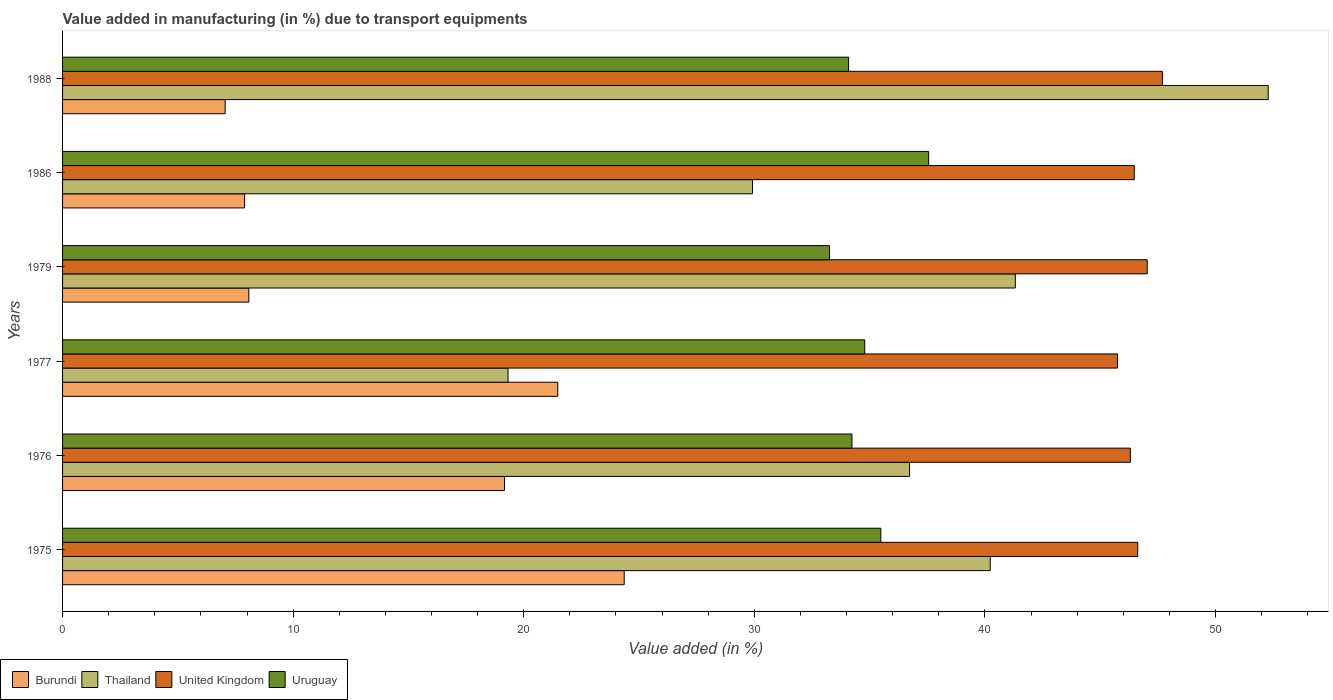Are the number of bars on each tick of the Y-axis equal?
Offer a very short reply. Yes. What is the label of the 5th group of bars from the top?
Your response must be concise. 1976. In how many cases, is the number of bars for a given year not equal to the number of legend labels?
Ensure brevity in your answer.  0. What is the percentage of value added in manufacturing due to transport equipments in Uruguay in 1988?
Keep it short and to the point. 34.09. Across all years, what is the maximum percentage of value added in manufacturing due to transport equipments in Thailand?
Offer a very short reply. 52.29. Across all years, what is the minimum percentage of value added in manufacturing due to transport equipments in Burundi?
Offer a terse response. 7.05. In which year was the percentage of value added in manufacturing due to transport equipments in United Kingdom maximum?
Provide a succinct answer. 1988. In which year was the percentage of value added in manufacturing due to transport equipments in Thailand minimum?
Your response must be concise. 1977. What is the total percentage of value added in manufacturing due to transport equipments in Uruguay in the graph?
Offer a very short reply. 209.43. What is the difference between the percentage of value added in manufacturing due to transport equipments in Burundi in 1977 and that in 1979?
Your answer should be compact. 13.4. What is the difference between the percentage of value added in manufacturing due to transport equipments in Thailand in 1977 and the percentage of value added in manufacturing due to transport equipments in Uruguay in 1976?
Provide a short and direct response. -14.92. What is the average percentage of value added in manufacturing due to transport equipments in Burundi per year?
Offer a terse response. 14.67. In the year 1977, what is the difference between the percentage of value added in manufacturing due to transport equipments in Burundi and percentage of value added in manufacturing due to transport equipments in United Kingdom?
Provide a short and direct response. -24.28. In how many years, is the percentage of value added in manufacturing due to transport equipments in Burundi greater than 12 %?
Your response must be concise. 3. What is the ratio of the percentage of value added in manufacturing due to transport equipments in United Kingdom in 1976 to that in 1986?
Ensure brevity in your answer.  1. Is the difference between the percentage of value added in manufacturing due to transport equipments in Burundi in 1975 and 1977 greater than the difference between the percentage of value added in manufacturing due to transport equipments in United Kingdom in 1975 and 1977?
Your answer should be compact. Yes. What is the difference between the highest and the second highest percentage of value added in manufacturing due to transport equipments in United Kingdom?
Make the answer very short. 0.66. What is the difference between the highest and the lowest percentage of value added in manufacturing due to transport equipments in Burundi?
Your response must be concise. 17.31. Is it the case that in every year, the sum of the percentage of value added in manufacturing due to transport equipments in Burundi and percentage of value added in manufacturing due to transport equipments in Thailand is greater than the sum of percentage of value added in manufacturing due to transport equipments in United Kingdom and percentage of value added in manufacturing due to transport equipments in Uruguay?
Give a very brief answer. No. What does the 4th bar from the bottom in 1988 represents?
Keep it short and to the point. Uruguay. How many years are there in the graph?
Make the answer very short. 6. What is the difference between two consecutive major ticks on the X-axis?
Provide a short and direct response. 10. Are the values on the major ticks of X-axis written in scientific E-notation?
Keep it short and to the point. No. Where does the legend appear in the graph?
Your answer should be compact. Bottom left. How many legend labels are there?
Your answer should be compact. 4. What is the title of the graph?
Offer a terse response. Value added in manufacturing (in %) due to transport equipments. Does "St. Martin (French part)" appear as one of the legend labels in the graph?
Your response must be concise. No. What is the label or title of the X-axis?
Your answer should be compact. Value added (in %). What is the Value added (in %) of Burundi in 1975?
Your answer should be very brief. 24.36. What is the Value added (in %) in Thailand in 1975?
Make the answer very short. 40.23. What is the Value added (in %) in United Kingdom in 1975?
Ensure brevity in your answer.  46.63. What is the Value added (in %) of Uruguay in 1975?
Make the answer very short. 35.49. What is the Value added (in %) of Burundi in 1976?
Your response must be concise. 19.17. What is the Value added (in %) in Thailand in 1976?
Give a very brief answer. 36.73. What is the Value added (in %) of United Kingdom in 1976?
Your answer should be very brief. 46.31. What is the Value added (in %) of Uruguay in 1976?
Offer a terse response. 34.23. What is the Value added (in %) of Burundi in 1977?
Provide a succinct answer. 21.48. What is the Value added (in %) in Thailand in 1977?
Make the answer very short. 19.32. What is the Value added (in %) in United Kingdom in 1977?
Offer a terse response. 45.75. What is the Value added (in %) of Uruguay in 1977?
Give a very brief answer. 34.79. What is the Value added (in %) in Burundi in 1979?
Keep it short and to the point. 8.08. What is the Value added (in %) of Thailand in 1979?
Your response must be concise. 41.32. What is the Value added (in %) in United Kingdom in 1979?
Your response must be concise. 47.04. What is the Value added (in %) of Uruguay in 1979?
Keep it short and to the point. 33.27. What is the Value added (in %) of Burundi in 1986?
Offer a very short reply. 7.89. What is the Value added (in %) in Thailand in 1986?
Keep it short and to the point. 29.92. What is the Value added (in %) in United Kingdom in 1986?
Your response must be concise. 46.48. What is the Value added (in %) in Uruguay in 1986?
Give a very brief answer. 37.56. What is the Value added (in %) in Burundi in 1988?
Offer a very short reply. 7.05. What is the Value added (in %) in Thailand in 1988?
Give a very brief answer. 52.29. What is the Value added (in %) in United Kingdom in 1988?
Offer a very short reply. 47.7. What is the Value added (in %) of Uruguay in 1988?
Offer a very short reply. 34.09. Across all years, what is the maximum Value added (in %) of Burundi?
Make the answer very short. 24.36. Across all years, what is the maximum Value added (in %) in Thailand?
Your answer should be compact. 52.29. Across all years, what is the maximum Value added (in %) in United Kingdom?
Provide a succinct answer. 47.7. Across all years, what is the maximum Value added (in %) of Uruguay?
Offer a very short reply. 37.56. Across all years, what is the minimum Value added (in %) in Burundi?
Provide a succinct answer. 7.05. Across all years, what is the minimum Value added (in %) of Thailand?
Provide a short and direct response. 19.32. Across all years, what is the minimum Value added (in %) in United Kingdom?
Offer a very short reply. 45.75. Across all years, what is the minimum Value added (in %) in Uruguay?
Your answer should be very brief. 33.27. What is the total Value added (in %) of Burundi in the graph?
Offer a terse response. 88.02. What is the total Value added (in %) in Thailand in the graph?
Offer a terse response. 219.81. What is the total Value added (in %) of United Kingdom in the graph?
Offer a terse response. 279.91. What is the total Value added (in %) in Uruguay in the graph?
Keep it short and to the point. 209.43. What is the difference between the Value added (in %) of Burundi in 1975 and that in 1976?
Your response must be concise. 5.19. What is the difference between the Value added (in %) in Thailand in 1975 and that in 1976?
Provide a short and direct response. 3.5. What is the difference between the Value added (in %) in United Kingdom in 1975 and that in 1976?
Make the answer very short. 0.32. What is the difference between the Value added (in %) of Uruguay in 1975 and that in 1976?
Ensure brevity in your answer.  1.25. What is the difference between the Value added (in %) of Burundi in 1975 and that in 1977?
Ensure brevity in your answer.  2.88. What is the difference between the Value added (in %) of Thailand in 1975 and that in 1977?
Ensure brevity in your answer.  20.91. What is the difference between the Value added (in %) in United Kingdom in 1975 and that in 1977?
Your answer should be compact. 0.88. What is the difference between the Value added (in %) of Uruguay in 1975 and that in 1977?
Offer a terse response. 0.7. What is the difference between the Value added (in %) of Burundi in 1975 and that in 1979?
Your answer should be compact. 16.28. What is the difference between the Value added (in %) in Thailand in 1975 and that in 1979?
Give a very brief answer. -1.09. What is the difference between the Value added (in %) of United Kingdom in 1975 and that in 1979?
Ensure brevity in your answer.  -0.41. What is the difference between the Value added (in %) in Uruguay in 1975 and that in 1979?
Offer a terse response. 2.22. What is the difference between the Value added (in %) of Burundi in 1975 and that in 1986?
Your answer should be very brief. 16.46. What is the difference between the Value added (in %) in Thailand in 1975 and that in 1986?
Your answer should be compact. 10.31. What is the difference between the Value added (in %) of United Kingdom in 1975 and that in 1986?
Provide a succinct answer. 0.15. What is the difference between the Value added (in %) of Uruguay in 1975 and that in 1986?
Provide a short and direct response. -2.07. What is the difference between the Value added (in %) of Burundi in 1975 and that in 1988?
Provide a short and direct response. 17.31. What is the difference between the Value added (in %) of Thailand in 1975 and that in 1988?
Keep it short and to the point. -12.06. What is the difference between the Value added (in %) of United Kingdom in 1975 and that in 1988?
Ensure brevity in your answer.  -1.07. What is the difference between the Value added (in %) of Uruguay in 1975 and that in 1988?
Your answer should be very brief. 1.4. What is the difference between the Value added (in %) in Burundi in 1976 and that in 1977?
Provide a succinct answer. -2.31. What is the difference between the Value added (in %) of Thailand in 1976 and that in 1977?
Provide a short and direct response. 17.41. What is the difference between the Value added (in %) of United Kingdom in 1976 and that in 1977?
Offer a terse response. 0.56. What is the difference between the Value added (in %) in Uruguay in 1976 and that in 1977?
Provide a succinct answer. -0.56. What is the difference between the Value added (in %) of Burundi in 1976 and that in 1979?
Keep it short and to the point. 11.09. What is the difference between the Value added (in %) in Thailand in 1976 and that in 1979?
Provide a short and direct response. -4.59. What is the difference between the Value added (in %) in United Kingdom in 1976 and that in 1979?
Provide a succinct answer. -0.73. What is the difference between the Value added (in %) in Uruguay in 1976 and that in 1979?
Offer a very short reply. 0.97. What is the difference between the Value added (in %) of Burundi in 1976 and that in 1986?
Offer a very short reply. 11.27. What is the difference between the Value added (in %) in Thailand in 1976 and that in 1986?
Your answer should be compact. 6.81. What is the difference between the Value added (in %) of United Kingdom in 1976 and that in 1986?
Your answer should be very brief. -0.17. What is the difference between the Value added (in %) of Uruguay in 1976 and that in 1986?
Offer a terse response. -3.33. What is the difference between the Value added (in %) of Burundi in 1976 and that in 1988?
Your answer should be compact. 12.12. What is the difference between the Value added (in %) in Thailand in 1976 and that in 1988?
Ensure brevity in your answer.  -15.55. What is the difference between the Value added (in %) in United Kingdom in 1976 and that in 1988?
Offer a very short reply. -1.39. What is the difference between the Value added (in %) of Uruguay in 1976 and that in 1988?
Provide a short and direct response. 0.14. What is the difference between the Value added (in %) of Burundi in 1977 and that in 1979?
Offer a very short reply. 13.4. What is the difference between the Value added (in %) of Thailand in 1977 and that in 1979?
Offer a very short reply. -22. What is the difference between the Value added (in %) in United Kingdom in 1977 and that in 1979?
Give a very brief answer. -1.29. What is the difference between the Value added (in %) in Uruguay in 1977 and that in 1979?
Your response must be concise. 1.52. What is the difference between the Value added (in %) in Burundi in 1977 and that in 1986?
Your answer should be very brief. 13.58. What is the difference between the Value added (in %) of Thailand in 1977 and that in 1986?
Your answer should be very brief. -10.6. What is the difference between the Value added (in %) of United Kingdom in 1977 and that in 1986?
Provide a succinct answer. -0.72. What is the difference between the Value added (in %) of Uruguay in 1977 and that in 1986?
Provide a short and direct response. -2.77. What is the difference between the Value added (in %) in Burundi in 1977 and that in 1988?
Your response must be concise. 14.43. What is the difference between the Value added (in %) of Thailand in 1977 and that in 1988?
Provide a short and direct response. -32.97. What is the difference between the Value added (in %) of United Kingdom in 1977 and that in 1988?
Keep it short and to the point. -1.95. What is the difference between the Value added (in %) of Uruguay in 1977 and that in 1988?
Ensure brevity in your answer.  0.7. What is the difference between the Value added (in %) in Burundi in 1979 and that in 1986?
Provide a succinct answer. 0.18. What is the difference between the Value added (in %) of Thailand in 1979 and that in 1986?
Your answer should be very brief. 11.4. What is the difference between the Value added (in %) in United Kingdom in 1979 and that in 1986?
Ensure brevity in your answer.  0.56. What is the difference between the Value added (in %) in Uruguay in 1979 and that in 1986?
Your answer should be compact. -4.3. What is the difference between the Value added (in %) in Burundi in 1979 and that in 1988?
Your answer should be very brief. 1.03. What is the difference between the Value added (in %) in Thailand in 1979 and that in 1988?
Make the answer very short. -10.97. What is the difference between the Value added (in %) in United Kingdom in 1979 and that in 1988?
Offer a very short reply. -0.66. What is the difference between the Value added (in %) in Uruguay in 1979 and that in 1988?
Your answer should be compact. -0.82. What is the difference between the Value added (in %) in Burundi in 1986 and that in 1988?
Your answer should be compact. 0.84. What is the difference between the Value added (in %) of Thailand in 1986 and that in 1988?
Provide a short and direct response. -22.37. What is the difference between the Value added (in %) of United Kingdom in 1986 and that in 1988?
Your response must be concise. -1.22. What is the difference between the Value added (in %) of Uruguay in 1986 and that in 1988?
Your response must be concise. 3.47. What is the difference between the Value added (in %) of Burundi in 1975 and the Value added (in %) of Thailand in 1976?
Your answer should be very brief. -12.38. What is the difference between the Value added (in %) of Burundi in 1975 and the Value added (in %) of United Kingdom in 1976?
Make the answer very short. -21.95. What is the difference between the Value added (in %) of Burundi in 1975 and the Value added (in %) of Uruguay in 1976?
Offer a terse response. -9.88. What is the difference between the Value added (in %) of Thailand in 1975 and the Value added (in %) of United Kingdom in 1976?
Ensure brevity in your answer.  -6.08. What is the difference between the Value added (in %) in Thailand in 1975 and the Value added (in %) in Uruguay in 1976?
Ensure brevity in your answer.  6. What is the difference between the Value added (in %) of United Kingdom in 1975 and the Value added (in %) of Uruguay in 1976?
Offer a terse response. 12.39. What is the difference between the Value added (in %) of Burundi in 1975 and the Value added (in %) of Thailand in 1977?
Ensure brevity in your answer.  5.04. What is the difference between the Value added (in %) in Burundi in 1975 and the Value added (in %) in United Kingdom in 1977?
Provide a short and direct response. -21.4. What is the difference between the Value added (in %) of Burundi in 1975 and the Value added (in %) of Uruguay in 1977?
Make the answer very short. -10.43. What is the difference between the Value added (in %) of Thailand in 1975 and the Value added (in %) of United Kingdom in 1977?
Provide a short and direct response. -5.52. What is the difference between the Value added (in %) in Thailand in 1975 and the Value added (in %) in Uruguay in 1977?
Offer a terse response. 5.44. What is the difference between the Value added (in %) in United Kingdom in 1975 and the Value added (in %) in Uruguay in 1977?
Offer a very short reply. 11.84. What is the difference between the Value added (in %) of Burundi in 1975 and the Value added (in %) of Thailand in 1979?
Provide a succinct answer. -16.96. What is the difference between the Value added (in %) in Burundi in 1975 and the Value added (in %) in United Kingdom in 1979?
Keep it short and to the point. -22.68. What is the difference between the Value added (in %) in Burundi in 1975 and the Value added (in %) in Uruguay in 1979?
Make the answer very short. -8.91. What is the difference between the Value added (in %) in Thailand in 1975 and the Value added (in %) in United Kingdom in 1979?
Make the answer very short. -6.81. What is the difference between the Value added (in %) of Thailand in 1975 and the Value added (in %) of Uruguay in 1979?
Ensure brevity in your answer.  6.97. What is the difference between the Value added (in %) of United Kingdom in 1975 and the Value added (in %) of Uruguay in 1979?
Provide a short and direct response. 13.36. What is the difference between the Value added (in %) of Burundi in 1975 and the Value added (in %) of Thailand in 1986?
Ensure brevity in your answer.  -5.56. What is the difference between the Value added (in %) in Burundi in 1975 and the Value added (in %) in United Kingdom in 1986?
Make the answer very short. -22.12. What is the difference between the Value added (in %) of Burundi in 1975 and the Value added (in %) of Uruguay in 1986?
Offer a terse response. -13.2. What is the difference between the Value added (in %) in Thailand in 1975 and the Value added (in %) in United Kingdom in 1986?
Give a very brief answer. -6.25. What is the difference between the Value added (in %) in Thailand in 1975 and the Value added (in %) in Uruguay in 1986?
Give a very brief answer. 2.67. What is the difference between the Value added (in %) of United Kingdom in 1975 and the Value added (in %) of Uruguay in 1986?
Ensure brevity in your answer.  9.07. What is the difference between the Value added (in %) in Burundi in 1975 and the Value added (in %) in Thailand in 1988?
Provide a short and direct response. -27.93. What is the difference between the Value added (in %) in Burundi in 1975 and the Value added (in %) in United Kingdom in 1988?
Give a very brief answer. -23.34. What is the difference between the Value added (in %) of Burundi in 1975 and the Value added (in %) of Uruguay in 1988?
Offer a terse response. -9.73. What is the difference between the Value added (in %) in Thailand in 1975 and the Value added (in %) in United Kingdom in 1988?
Your response must be concise. -7.47. What is the difference between the Value added (in %) of Thailand in 1975 and the Value added (in %) of Uruguay in 1988?
Your answer should be compact. 6.14. What is the difference between the Value added (in %) in United Kingdom in 1975 and the Value added (in %) in Uruguay in 1988?
Your answer should be very brief. 12.54. What is the difference between the Value added (in %) in Burundi in 1976 and the Value added (in %) in Thailand in 1977?
Your answer should be compact. -0.15. What is the difference between the Value added (in %) in Burundi in 1976 and the Value added (in %) in United Kingdom in 1977?
Give a very brief answer. -26.59. What is the difference between the Value added (in %) of Burundi in 1976 and the Value added (in %) of Uruguay in 1977?
Your response must be concise. -15.62. What is the difference between the Value added (in %) of Thailand in 1976 and the Value added (in %) of United Kingdom in 1977?
Offer a terse response. -9.02. What is the difference between the Value added (in %) of Thailand in 1976 and the Value added (in %) of Uruguay in 1977?
Provide a succinct answer. 1.94. What is the difference between the Value added (in %) of United Kingdom in 1976 and the Value added (in %) of Uruguay in 1977?
Give a very brief answer. 11.52. What is the difference between the Value added (in %) in Burundi in 1976 and the Value added (in %) in Thailand in 1979?
Your answer should be compact. -22.15. What is the difference between the Value added (in %) of Burundi in 1976 and the Value added (in %) of United Kingdom in 1979?
Your response must be concise. -27.87. What is the difference between the Value added (in %) of Burundi in 1976 and the Value added (in %) of Uruguay in 1979?
Offer a very short reply. -14.1. What is the difference between the Value added (in %) of Thailand in 1976 and the Value added (in %) of United Kingdom in 1979?
Provide a succinct answer. -10.31. What is the difference between the Value added (in %) in Thailand in 1976 and the Value added (in %) in Uruguay in 1979?
Provide a succinct answer. 3.47. What is the difference between the Value added (in %) in United Kingdom in 1976 and the Value added (in %) in Uruguay in 1979?
Your response must be concise. 13.04. What is the difference between the Value added (in %) in Burundi in 1976 and the Value added (in %) in Thailand in 1986?
Provide a short and direct response. -10.75. What is the difference between the Value added (in %) in Burundi in 1976 and the Value added (in %) in United Kingdom in 1986?
Ensure brevity in your answer.  -27.31. What is the difference between the Value added (in %) of Burundi in 1976 and the Value added (in %) of Uruguay in 1986?
Offer a terse response. -18.4. What is the difference between the Value added (in %) of Thailand in 1976 and the Value added (in %) of United Kingdom in 1986?
Offer a terse response. -9.74. What is the difference between the Value added (in %) of Thailand in 1976 and the Value added (in %) of Uruguay in 1986?
Your response must be concise. -0.83. What is the difference between the Value added (in %) in United Kingdom in 1976 and the Value added (in %) in Uruguay in 1986?
Your answer should be compact. 8.75. What is the difference between the Value added (in %) in Burundi in 1976 and the Value added (in %) in Thailand in 1988?
Provide a short and direct response. -33.12. What is the difference between the Value added (in %) of Burundi in 1976 and the Value added (in %) of United Kingdom in 1988?
Offer a very short reply. -28.53. What is the difference between the Value added (in %) in Burundi in 1976 and the Value added (in %) in Uruguay in 1988?
Your response must be concise. -14.92. What is the difference between the Value added (in %) of Thailand in 1976 and the Value added (in %) of United Kingdom in 1988?
Provide a short and direct response. -10.97. What is the difference between the Value added (in %) of Thailand in 1976 and the Value added (in %) of Uruguay in 1988?
Keep it short and to the point. 2.64. What is the difference between the Value added (in %) in United Kingdom in 1976 and the Value added (in %) in Uruguay in 1988?
Keep it short and to the point. 12.22. What is the difference between the Value added (in %) in Burundi in 1977 and the Value added (in %) in Thailand in 1979?
Provide a short and direct response. -19.84. What is the difference between the Value added (in %) in Burundi in 1977 and the Value added (in %) in United Kingdom in 1979?
Give a very brief answer. -25.56. What is the difference between the Value added (in %) in Burundi in 1977 and the Value added (in %) in Uruguay in 1979?
Your answer should be very brief. -11.79. What is the difference between the Value added (in %) of Thailand in 1977 and the Value added (in %) of United Kingdom in 1979?
Keep it short and to the point. -27.72. What is the difference between the Value added (in %) of Thailand in 1977 and the Value added (in %) of Uruguay in 1979?
Give a very brief answer. -13.95. What is the difference between the Value added (in %) in United Kingdom in 1977 and the Value added (in %) in Uruguay in 1979?
Your response must be concise. 12.49. What is the difference between the Value added (in %) of Burundi in 1977 and the Value added (in %) of Thailand in 1986?
Make the answer very short. -8.44. What is the difference between the Value added (in %) of Burundi in 1977 and the Value added (in %) of United Kingdom in 1986?
Your answer should be compact. -25. What is the difference between the Value added (in %) of Burundi in 1977 and the Value added (in %) of Uruguay in 1986?
Your answer should be compact. -16.08. What is the difference between the Value added (in %) of Thailand in 1977 and the Value added (in %) of United Kingdom in 1986?
Your response must be concise. -27.16. What is the difference between the Value added (in %) of Thailand in 1977 and the Value added (in %) of Uruguay in 1986?
Your answer should be very brief. -18.24. What is the difference between the Value added (in %) in United Kingdom in 1977 and the Value added (in %) in Uruguay in 1986?
Your answer should be compact. 8.19. What is the difference between the Value added (in %) in Burundi in 1977 and the Value added (in %) in Thailand in 1988?
Provide a short and direct response. -30.81. What is the difference between the Value added (in %) of Burundi in 1977 and the Value added (in %) of United Kingdom in 1988?
Your answer should be very brief. -26.22. What is the difference between the Value added (in %) in Burundi in 1977 and the Value added (in %) in Uruguay in 1988?
Your response must be concise. -12.61. What is the difference between the Value added (in %) of Thailand in 1977 and the Value added (in %) of United Kingdom in 1988?
Keep it short and to the point. -28.38. What is the difference between the Value added (in %) in Thailand in 1977 and the Value added (in %) in Uruguay in 1988?
Your response must be concise. -14.77. What is the difference between the Value added (in %) in United Kingdom in 1977 and the Value added (in %) in Uruguay in 1988?
Keep it short and to the point. 11.66. What is the difference between the Value added (in %) of Burundi in 1979 and the Value added (in %) of Thailand in 1986?
Give a very brief answer. -21.84. What is the difference between the Value added (in %) of Burundi in 1979 and the Value added (in %) of United Kingdom in 1986?
Offer a very short reply. -38.4. What is the difference between the Value added (in %) in Burundi in 1979 and the Value added (in %) in Uruguay in 1986?
Ensure brevity in your answer.  -29.48. What is the difference between the Value added (in %) in Thailand in 1979 and the Value added (in %) in United Kingdom in 1986?
Provide a succinct answer. -5.16. What is the difference between the Value added (in %) in Thailand in 1979 and the Value added (in %) in Uruguay in 1986?
Ensure brevity in your answer.  3.76. What is the difference between the Value added (in %) of United Kingdom in 1979 and the Value added (in %) of Uruguay in 1986?
Ensure brevity in your answer.  9.48. What is the difference between the Value added (in %) of Burundi in 1979 and the Value added (in %) of Thailand in 1988?
Keep it short and to the point. -44.21. What is the difference between the Value added (in %) in Burundi in 1979 and the Value added (in %) in United Kingdom in 1988?
Offer a terse response. -39.62. What is the difference between the Value added (in %) in Burundi in 1979 and the Value added (in %) in Uruguay in 1988?
Your response must be concise. -26.01. What is the difference between the Value added (in %) of Thailand in 1979 and the Value added (in %) of United Kingdom in 1988?
Your answer should be very brief. -6.38. What is the difference between the Value added (in %) in Thailand in 1979 and the Value added (in %) in Uruguay in 1988?
Ensure brevity in your answer.  7.23. What is the difference between the Value added (in %) of United Kingdom in 1979 and the Value added (in %) of Uruguay in 1988?
Ensure brevity in your answer.  12.95. What is the difference between the Value added (in %) of Burundi in 1986 and the Value added (in %) of Thailand in 1988?
Ensure brevity in your answer.  -44.39. What is the difference between the Value added (in %) in Burundi in 1986 and the Value added (in %) in United Kingdom in 1988?
Offer a very short reply. -39.8. What is the difference between the Value added (in %) in Burundi in 1986 and the Value added (in %) in Uruguay in 1988?
Your response must be concise. -26.19. What is the difference between the Value added (in %) of Thailand in 1986 and the Value added (in %) of United Kingdom in 1988?
Give a very brief answer. -17.78. What is the difference between the Value added (in %) of Thailand in 1986 and the Value added (in %) of Uruguay in 1988?
Keep it short and to the point. -4.17. What is the difference between the Value added (in %) in United Kingdom in 1986 and the Value added (in %) in Uruguay in 1988?
Ensure brevity in your answer.  12.39. What is the average Value added (in %) in Burundi per year?
Your response must be concise. 14.67. What is the average Value added (in %) of Thailand per year?
Provide a succinct answer. 36.64. What is the average Value added (in %) in United Kingdom per year?
Your answer should be compact. 46.65. What is the average Value added (in %) of Uruguay per year?
Your answer should be compact. 34.9. In the year 1975, what is the difference between the Value added (in %) of Burundi and Value added (in %) of Thailand?
Offer a very short reply. -15.87. In the year 1975, what is the difference between the Value added (in %) in Burundi and Value added (in %) in United Kingdom?
Provide a succinct answer. -22.27. In the year 1975, what is the difference between the Value added (in %) in Burundi and Value added (in %) in Uruguay?
Keep it short and to the point. -11.13. In the year 1975, what is the difference between the Value added (in %) in Thailand and Value added (in %) in United Kingdom?
Offer a very short reply. -6.4. In the year 1975, what is the difference between the Value added (in %) of Thailand and Value added (in %) of Uruguay?
Make the answer very short. 4.75. In the year 1975, what is the difference between the Value added (in %) in United Kingdom and Value added (in %) in Uruguay?
Offer a very short reply. 11.14. In the year 1976, what is the difference between the Value added (in %) in Burundi and Value added (in %) in Thailand?
Provide a succinct answer. -17.57. In the year 1976, what is the difference between the Value added (in %) in Burundi and Value added (in %) in United Kingdom?
Offer a very short reply. -27.14. In the year 1976, what is the difference between the Value added (in %) of Burundi and Value added (in %) of Uruguay?
Your answer should be very brief. -15.07. In the year 1976, what is the difference between the Value added (in %) of Thailand and Value added (in %) of United Kingdom?
Give a very brief answer. -9.58. In the year 1976, what is the difference between the Value added (in %) of Thailand and Value added (in %) of Uruguay?
Provide a short and direct response. 2.5. In the year 1976, what is the difference between the Value added (in %) of United Kingdom and Value added (in %) of Uruguay?
Give a very brief answer. 12.08. In the year 1977, what is the difference between the Value added (in %) of Burundi and Value added (in %) of Thailand?
Provide a short and direct response. 2.16. In the year 1977, what is the difference between the Value added (in %) in Burundi and Value added (in %) in United Kingdom?
Give a very brief answer. -24.28. In the year 1977, what is the difference between the Value added (in %) in Burundi and Value added (in %) in Uruguay?
Make the answer very short. -13.31. In the year 1977, what is the difference between the Value added (in %) of Thailand and Value added (in %) of United Kingdom?
Your answer should be very brief. -26.43. In the year 1977, what is the difference between the Value added (in %) in Thailand and Value added (in %) in Uruguay?
Give a very brief answer. -15.47. In the year 1977, what is the difference between the Value added (in %) in United Kingdom and Value added (in %) in Uruguay?
Ensure brevity in your answer.  10.96. In the year 1979, what is the difference between the Value added (in %) in Burundi and Value added (in %) in Thailand?
Provide a succinct answer. -33.24. In the year 1979, what is the difference between the Value added (in %) in Burundi and Value added (in %) in United Kingdom?
Ensure brevity in your answer.  -38.96. In the year 1979, what is the difference between the Value added (in %) in Burundi and Value added (in %) in Uruguay?
Offer a very short reply. -25.19. In the year 1979, what is the difference between the Value added (in %) of Thailand and Value added (in %) of United Kingdom?
Your answer should be very brief. -5.72. In the year 1979, what is the difference between the Value added (in %) in Thailand and Value added (in %) in Uruguay?
Ensure brevity in your answer.  8.05. In the year 1979, what is the difference between the Value added (in %) of United Kingdom and Value added (in %) of Uruguay?
Your answer should be compact. 13.77. In the year 1986, what is the difference between the Value added (in %) of Burundi and Value added (in %) of Thailand?
Offer a very short reply. -22.03. In the year 1986, what is the difference between the Value added (in %) of Burundi and Value added (in %) of United Kingdom?
Offer a very short reply. -38.58. In the year 1986, what is the difference between the Value added (in %) of Burundi and Value added (in %) of Uruguay?
Ensure brevity in your answer.  -29.67. In the year 1986, what is the difference between the Value added (in %) of Thailand and Value added (in %) of United Kingdom?
Provide a short and direct response. -16.56. In the year 1986, what is the difference between the Value added (in %) in Thailand and Value added (in %) in Uruguay?
Make the answer very short. -7.64. In the year 1986, what is the difference between the Value added (in %) of United Kingdom and Value added (in %) of Uruguay?
Provide a succinct answer. 8.92. In the year 1988, what is the difference between the Value added (in %) of Burundi and Value added (in %) of Thailand?
Offer a very short reply. -45.24. In the year 1988, what is the difference between the Value added (in %) in Burundi and Value added (in %) in United Kingdom?
Offer a very short reply. -40.65. In the year 1988, what is the difference between the Value added (in %) of Burundi and Value added (in %) of Uruguay?
Offer a terse response. -27.04. In the year 1988, what is the difference between the Value added (in %) in Thailand and Value added (in %) in United Kingdom?
Provide a succinct answer. 4.59. In the year 1988, what is the difference between the Value added (in %) of Thailand and Value added (in %) of Uruguay?
Offer a terse response. 18.2. In the year 1988, what is the difference between the Value added (in %) in United Kingdom and Value added (in %) in Uruguay?
Your answer should be compact. 13.61. What is the ratio of the Value added (in %) in Burundi in 1975 to that in 1976?
Your answer should be very brief. 1.27. What is the ratio of the Value added (in %) in Thailand in 1975 to that in 1976?
Keep it short and to the point. 1.1. What is the ratio of the Value added (in %) of United Kingdom in 1975 to that in 1976?
Offer a terse response. 1.01. What is the ratio of the Value added (in %) of Uruguay in 1975 to that in 1976?
Your answer should be very brief. 1.04. What is the ratio of the Value added (in %) in Burundi in 1975 to that in 1977?
Provide a short and direct response. 1.13. What is the ratio of the Value added (in %) of Thailand in 1975 to that in 1977?
Ensure brevity in your answer.  2.08. What is the ratio of the Value added (in %) of United Kingdom in 1975 to that in 1977?
Give a very brief answer. 1.02. What is the ratio of the Value added (in %) of Uruguay in 1975 to that in 1977?
Provide a succinct answer. 1.02. What is the ratio of the Value added (in %) in Burundi in 1975 to that in 1979?
Provide a short and direct response. 3.01. What is the ratio of the Value added (in %) in Thailand in 1975 to that in 1979?
Offer a very short reply. 0.97. What is the ratio of the Value added (in %) of United Kingdom in 1975 to that in 1979?
Offer a very short reply. 0.99. What is the ratio of the Value added (in %) of Uruguay in 1975 to that in 1979?
Provide a succinct answer. 1.07. What is the ratio of the Value added (in %) in Burundi in 1975 to that in 1986?
Your answer should be compact. 3.09. What is the ratio of the Value added (in %) of Thailand in 1975 to that in 1986?
Provide a short and direct response. 1.34. What is the ratio of the Value added (in %) in Uruguay in 1975 to that in 1986?
Offer a terse response. 0.94. What is the ratio of the Value added (in %) in Burundi in 1975 to that in 1988?
Your response must be concise. 3.45. What is the ratio of the Value added (in %) in Thailand in 1975 to that in 1988?
Your answer should be very brief. 0.77. What is the ratio of the Value added (in %) of United Kingdom in 1975 to that in 1988?
Give a very brief answer. 0.98. What is the ratio of the Value added (in %) of Uruguay in 1975 to that in 1988?
Your answer should be compact. 1.04. What is the ratio of the Value added (in %) in Burundi in 1976 to that in 1977?
Offer a terse response. 0.89. What is the ratio of the Value added (in %) of Thailand in 1976 to that in 1977?
Your answer should be very brief. 1.9. What is the ratio of the Value added (in %) in United Kingdom in 1976 to that in 1977?
Make the answer very short. 1.01. What is the ratio of the Value added (in %) of Burundi in 1976 to that in 1979?
Give a very brief answer. 2.37. What is the ratio of the Value added (in %) of Thailand in 1976 to that in 1979?
Ensure brevity in your answer.  0.89. What is the ratio of the Value added (in %) of United Kingdom in 1976 to that in 1979?
Provide a short and direct response. 0.98. What is the ratio of the Value added (in %) in Uruguay in 1976 to that in 1979?
Offer a terse response. 1.03. What is the ratio of the Value added (in %) in Burundi in 1976 to that in 1986?
Offer a very short reply. 2.43. What is the ratio of the Value added (in %) in Thailand in 1976 to that in 1986?
Make the answer very short. 1.23. What is the ratio of the Value added (in %) in Uruguay in 1976 to that in 1986?
Give a very brief answer. 0.91. What is the ratio of the Value added (in %) in Burundi in 1976 to that in 1988?
Offer a terse response. 2.72. What is the ratio of the Value added (in %) of Thailand in 1976 to that in 1988?
Your answer should be very brief. 0.7. What is the ratio of the Value added (in %) of United Kingdom in 1976 to that in 1988?
Offer a very short reply. 0.97. What is the ratio of the Value added (in %) in Burundi in 1977 to that in 1979?
Provide a short and direct response. 2.66. What is the ratio of the Value added (in %) of Thailand in 1977 to that in 1979?
Keep it short and to the point. 0.47. What is the ratio of the Value added (in %) of United Kingdom in 1977 to that in 1979?
Your answer should be compact. 0.97. What is the ratio of the Value added (in %) in Uruguay in 1977 to that in 1979?
Offer a very short reply. 1.05. What is the ratio of the Value added (in %) of Burundi in 1977 to that in 1986?
Your answer should be very brief. 2.72. What is the ratio of the Value added (in %) of Thailand in 1977 to that in 1986?
Offer a very short reply. 0.65. What is the ratio of the Value added (in %) in United Kingdom in 1977 to that in 1986?
Your answer should be compact. 0.98. What is the ratio of the Value added (in %) in Uruguay in 1977 to that in 1986?
Give a very brief answer. 0.93. What is the ratio of the Value added (in %) of Burundi in 1977 to that in 1988?
Make the answer very short. 3.05. What is the ratio of the Value added (in %) of Thailand in 1977 to that in 1988?
Provide a succinct answer. 0.37. What is the ratio of the Value added (in %) in United Kingdom in 1977 to that in 1988?
Offer a very short reply. 0.96. What is the ratio of the Value added (in %) in Uruguay in 1977 to that in 1988?
Your answer should be very brief. 1.02. What is the ratio of the Value added (in %) in Burundi in 1979 to that in 1986?
Give a very brief answer. 1.02. What is the ratio of the Value added (in %) of Thailand in 1979 to that in 1986?
Give a very brief answer. 1.38. What is the ratio of the Value added (in %) of United Kingdom in 1979 to that in 1986?
Provide a short and direct response. 1.01. What is the ratio of the Value added (in %) in Uruguay in 1979 to that in 1986?
Your response must be concise. 0.89. What is the ratio of the Value added (in %) in Burundi in 1979 to that in 1988?
Your answer should be very brief. 1.15. What is the ratio of the Value added (in %) of Thailand in 1979 to that in 1988?
Offer a very short reply. 0.79. What is the ratio of the Value added (in %) of United Kingdom in 1979 to that in 1988?
Provide a short and direct response. 0.99. What is the ratio of the Value added (in %) of Uruguay in 1979 to that in 1988?
Give a very brief answer. 0.98. What is the ratio of the Value added (in %) of Burundi in 1986 to that in 1988?
Your answer should be very brief. 1.12. What is the ratio of the Value added (in %) of Thailand in 1986 to that in 1988?
Give a very brief answer. 0.57. What is the ratio of the Value added (in %) in United Kingdom in 1986 to that in 1988?
Ensure brevity in your answer.  0.97. What is the ratio of the Value added (in %) in Uruguay in 1986 to that in 1988?
Give a very brief answer. 1.1. What is the difference between the highest and the second highest Value added (in %) of Burundi?
Ensure brevity in your answer.  2.88. What is the difference between the highest and the second highest Value added (in %) of Thailand?
Your answer should be very brief. 10.97. What is the difference between the highest and the second highest Value added (in %) in United Kingdom?
Provide a short and direct response. 0.66. What is the difference between the highest and the second highest Value added (in %) in Uruguay?
Make the answer very short. 2.07. What is the difference between the highest and the lowest Value added (in %) in Burundi?
Make the answer very short. 17.31. What is the difference between the highest and the lowest Value added (in %) in Thailand?
Make the answer very short. 32.97. What is the difference between the highest and the lowest Value added (in %) in United Kingdom?
Your response must be concise. 1.95. What is the difference between the highest and the lowest Value added (in %) in Uruguay?
Your response must be concise. 4.3. 